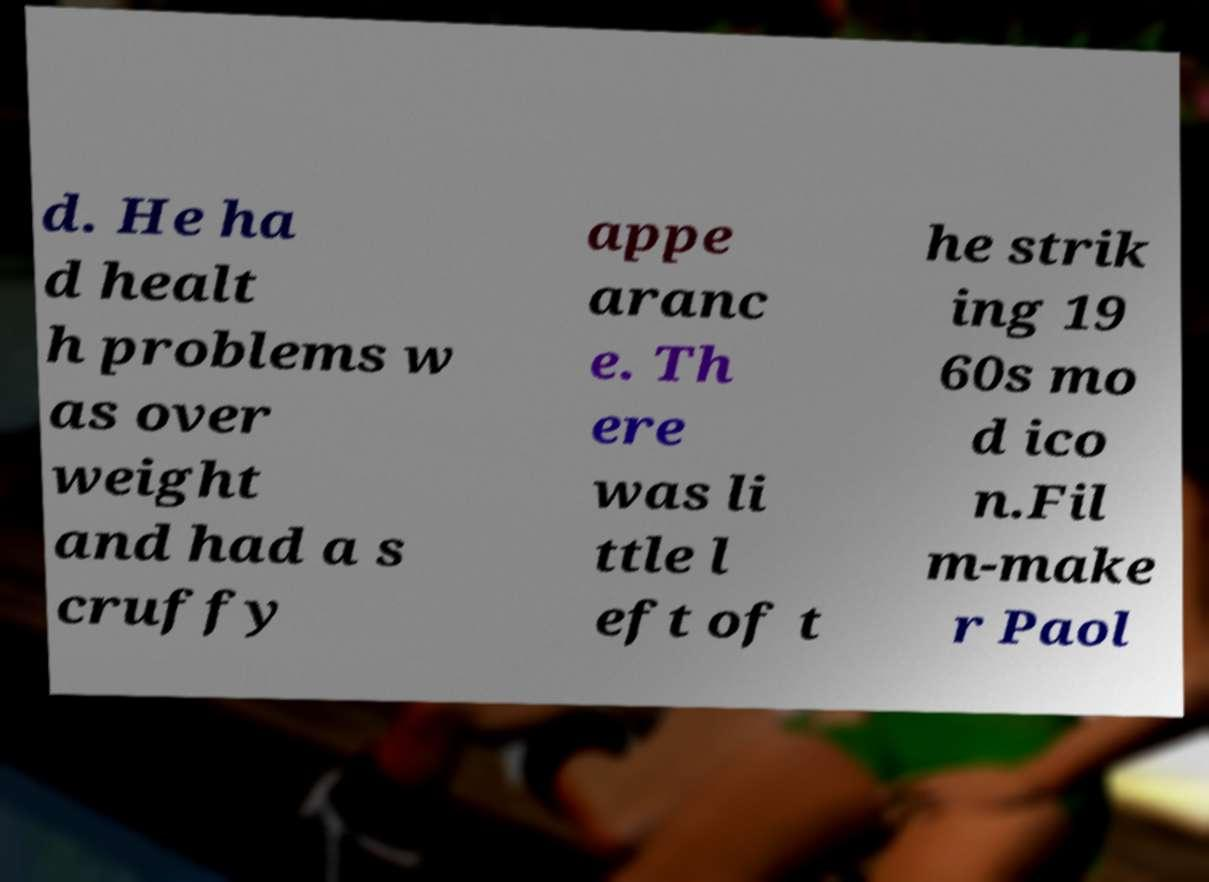What messages or text are displayed in this image? I need them in a readable, typed format. d. He ha d healt h problems w as over weight and had a s cruffy appe aranc e. Th ere was li ttle l eft of t he strik ing 19 60s mo d ico n.Fil m-make r Paol 